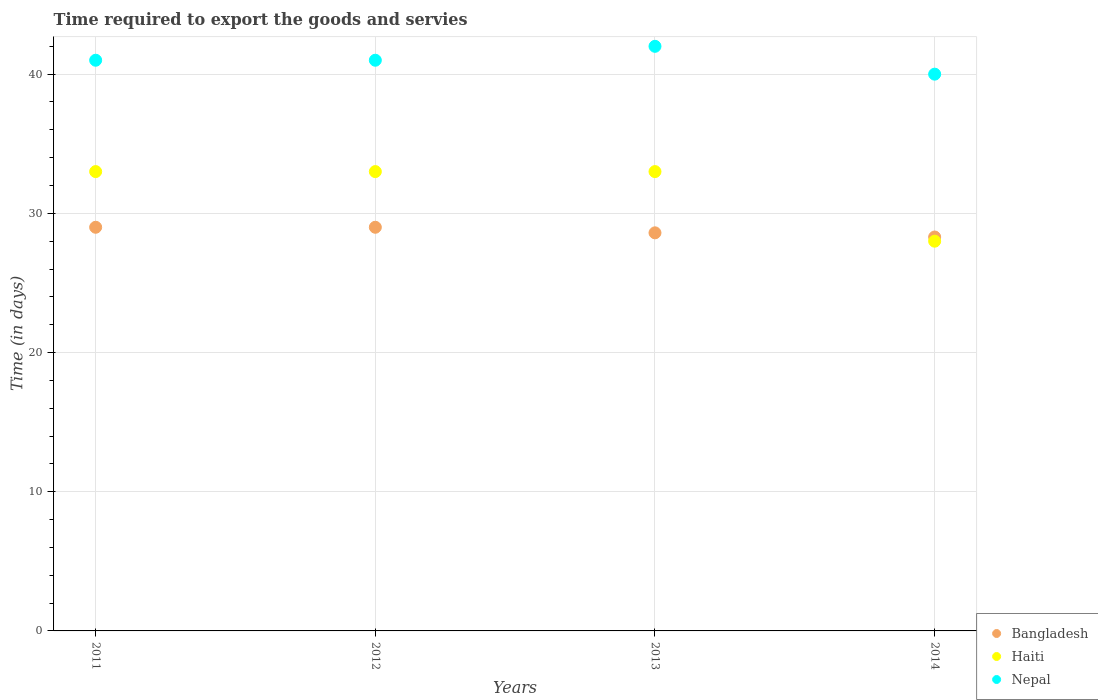Is the number of dotlines equal to the number of legend labels?
Your answer should be very brief. Yes. What is the number of days required to export the goods and services in Haiti in 2013?
Make the answer very short. 33. Across all years, what is the maximum number of days required to export the goods and services in Nepal?
Give a very brief answer. 42. Across all years, what is the minimum number of days required to export the goods and services in Haiti?
Make the answer very short. 28. What is the total number of days required to export the goods and services in Haiti in the graph?
Make the answer very short. 127. What is the difference between the number of days required to export the goods and services in Nepal in 2011 and that in 2014?
Give a very brief answer. 1. What is the difference between the number of days required to export the goods and services in Nepal in 2011 and the number of days required to export the goods and services in Bangladesh in 2013?
Provide a succinct answer. 12.4. What is the average number of days required to export the goods and services in Bangladesh per year?
Your answer should be very brief. 28.72. What is the ratio of the number of days required to export the goods and services in Haiti in 2011 to that in 2013?
Make the answer very short. 1. Is the number of days required to export the goods and services in Haiti in 2013 less than that in 2014?
Offer a terse response. No. Is the difference between the number of days required to export the goods and services in Nepal in 2011 and 2014 greater than the difference between the number of days required to export the goods and services in Bangladesh in 2011 and 2014?
Keep it short and to the point. Yes. What is the difference between the highest and the second highest number of days required to export the goods and services in Nepal?
Your response must be concise. 1. What is the difference between the highest and the lowest number of days required to export the goods and services in Haiti?
Provide a short and direct response. 5. Is the sum of the number of days required to export the goods and services in Bangladesh in 2012 and 2014 greater than the maximum number of days required to export the goods and services in Nepal across all years?
Keep it short and to the point. Yes. How many years are there in the graph?
Your answer should be compact. 4. Are the values on the major ticks of Y-axis written in scientific E-notation?
Offer a very short reply. No. Does the graph contain any zero values?
Make the answer very short. No. How are the legend labels stacked?
Your answer should be very brief. Vertical. What is the title of the graph?
Your response must be concise. Time required to export the goods and servies. What is the label or title of the X-axis?
Your answer should be very brief. Years. What is the label or title of the Y-axis?
Provide a succinct answer. Time (in days). What is the Time (in days) in Haiti in 2011?
Offer a terse response. 33. What is the Time (in days) in Nepal in 2011?
Offer a very short reply. 41. What is the Time (in days) in Bangladesh in 2012?
Your response must be concise. 29. What is the Time (in days) of Haiti in 2012?
Offer a terse response. 33. What is the Time (in days) in Bangladesh in 2013?
Your answer should be compact. 28.6. What is the Time (in days) in Haiti in 2013?
Your answer should be very brief. 33. What is the Time (in days) of Nepal in 2013?
Make the answer very short. 42. What is the Time (in days) of Bangladesh in 2014?
Give a very brief answer. 28.3. What is the Time (in days) in Haiti in 2014?
Offer a very short reply. 28. What is the Time (in days) in Nepal in 2014?
Give a very brief answer. 40. Across all years, what is the maximum Time (in days) in Bangladesh?
Provide a short and direct response. 29. Across all years, what is the minimum Time (in days) in Bangladesh?
Provide a short and direct response. 28.3. Across all years, what is the minimum Time (in days) of Haiti?
Provide a short and direct response. 28. Across all years, what is the minimum Time (in days) of Nepal?
Offer a very short reply. 40. What is the total Time (in days) in Bangladesh in the graph?
Provide a succinct answer. 114.9. What is the total Time (in days) in Haiti in the graph?
Make the answer very short. 127. What is the total Time (in days) of Nepal in the graph?
Offer a very short reply. 164. What is the difference between the Time (in days) in Haiti in 2011 and that in 2012?
Offer a terse response. 0. What is the difference between the Time (in days) in Bangladesh in 2011 and that in 2014?
Provide a succinct answer. 0.7. What is the difference between the Time (in days) of Nepal in 2012 and that in 2013?
Make the answer very short. -1. What is the difference between the Time (in days) of Bangladesh in 2013 and that in 2014?
Provide a succinct answer. 0.3. What is the difference between the Time (in days) in Haiti in 2011 and the Time (in days) in Nepal in 2012?
Give a very brief answer. -8. What is the difference between the Time (in days) of Bangladesh in 2011 and the Time (in days) of Haiti in 2013?
Your answer should be very brief. -4. What is the difference between the Time (in days) in Bangladesh in 2011 and the Time (in days) in Nepal in 2014?
Keep it short and to the point. -11. What is the difference between the Time (in days) in Haiti in 2011 and the Time (in days) in Nepal in 2014?
Ensure brevity in your answer.  -7. What is the difference between the Time (in days) of Haiti in 2012 and the Time (in days) of Nepal in 2013?
Give a very brief answer. -9. What is the difference between the Time (in days) of Bangladesh in 2012 and the Time (in days) of Haiti in 2014?
Give a very brief answer. 1. What is the difference between the Time (in days) of Bangladesh in 2013 and the Time (in days) of Haiti in 2014?
Your response must be concise. 0.6. What is the difference between the Time (in days) of Bangladesh in 2013 and the Time (in days) of Nepal in 2014?
Offer a terse response. -11.4. What is the average Time (in days) of Bangladesh per year?
Provide a short and direct response. 28.73. What is the average Time (in days) of Haiti per year?
Your answer should be very brief. 31.75. What is the average Time (in days) in Nepal per year?
Keep it short and to the point. 41. In the year 2011, what is the difference between the Time (in days) of Haiti and Time (in days) of Nepal?
Give a very brief answer. -8. In the year 2012, what is the difference between the Time (in days) of Bangladesh and Time (in days) of Haiti?
Give a very brief answer. -4. In the year 2012, what is the difference between the Time (in days) in Bangladesh and Time (in days) in Nepal?
Offer a terse response. -12. In the year 2013, what is the difference between the Time (in days) of Bangladesh and Time (in days) of Haiti?
Offer a very short reply. -4.4. In the year 2014, what is the difference between the Time (in days) in Bangladesh and Time (in days) in Haiti?
Your response must be concise. 0.3. In the year 2014, what is the difference between the Time (in days) of Bangladesh and Time (in days) of Nepal?
Your answer should be very brief. -11.7. In the year 2014, what is the difference between the Time (in days) of Haiti and Time (in days) of Nepal?
Keep it short and to the point. -12. What is the ratio of the Time (in days) of Nepal in 2011 to that in 2012?
Your answer should be compact. 1. What is the ratio of the Time (in days) in Haiti in 2011 to that in 2013?
Your answer should be compact. 1. What is the ratio of the Time (in days) in Nepal in 2011 to that in 2013?
Your answer should be very brief. 0.98. What is the ratio of the Time (in days) of Bangladesh in 2011 to that in 2014?
Offer a very short reply. 1.02. What is the ratio of the Time (in days) of Haiti in 2011 to that in 2014?
Keep it short and to the point. 1.18. What is the ratio of the Time (in days) of Nepal in 2011 to that in 2014?
Provide a succinct answer. 1.02. What is the ratio of the Time (in days) of Nepal in 2012 to that in 2013?
Your response must be concise. 0.98. What is the ratio of the Time (in days) of Bangladesh in 2012 to that in 2014?
Offer a terse response. 1.02. What is the ratio of the Time (in days) in Haiti in 2012 to that in 2014?
Offer a very short reply. 1.18. What is the ratio of the Time (in days) in Nepal in 2012 to that in 2014?
Your response must be concise. 1.02. What is the ratio of the Time (in days) of Bangladesh in 2013 to that in 2014?
Give a very brief answer. 1.01. What is the ratio of the Time (in days) in Haiti in 2013 to that in 2014?
Give a very brief answer. 1.18. What is the ratio of the Time (in days) of Nepal in 2013 to that in 2014?
Ensure brevity in your answer.  1.05. What is the difference between the highest and the second highest Time (in days) of Bangladesh?
Offer a very short reply. 0. What is the difference between the highest and the second highest Time (in days) of Haiti?
Give a very brief answer. 0. What is the difference between the highest and the second highest Time (in days) in Nepal?
Make the answer very short. 1. What is the difference between the highest and the lowest Time (in days) of Haiti?
Offer a terse response. 5. What is the difference between the highest and the lowest Time (in days) in Nepal?
Your answer should be compact. 2. 